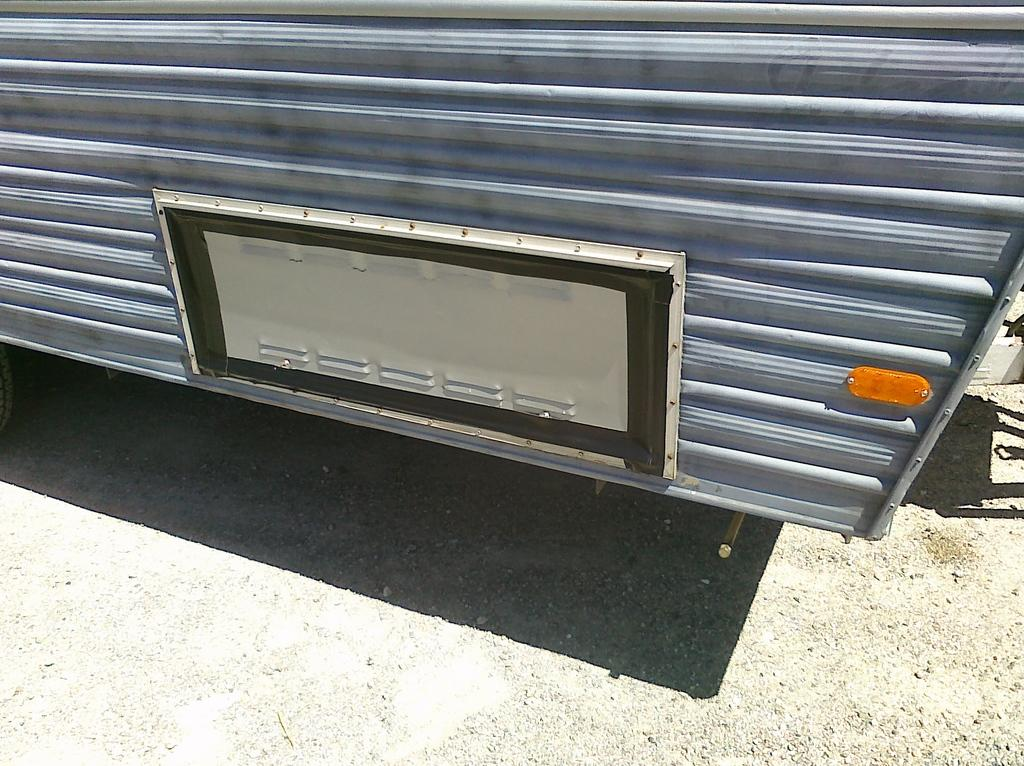What is the main subject of the image? The main subject of the image is a zoomed in picture of a vehicle. Can you describe the setting in which the vehicle is located? There is a road visible at the bottom of the image. What type of knowledge is the vehicle gaining from the activity on the sidewalk? There is no sidewalk present in the image, and the vehicle is not gaining any knowledge from an activity. 